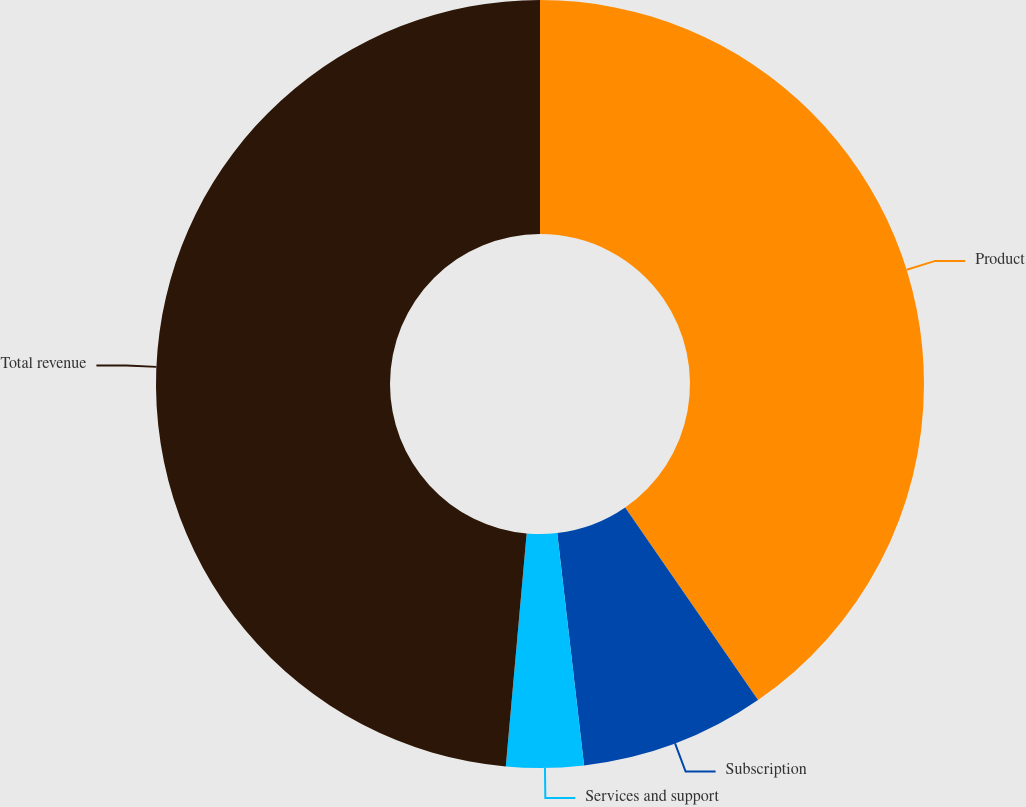Convert chart. <chart><loc_0><loc_0><loc_500><loc_500><pie_chart><fcel>Product<fcel>Subscription<fcel>Services and support<fcel>Total revenue<nl><fcel>40.39%<fcel>7.78%<fcel>3.25%<fcel>48.58%<nl></chart> 